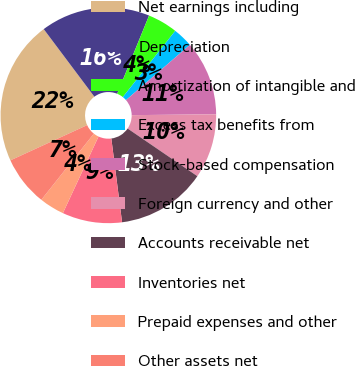Convert chart to OTSL. <chart><loc_0><loc_0><loc_500><loc_500><pie_chart><fcel>Net earnings including<fcel>Depreciation<fcel>Amortization of intangible and<fcel>Excess tax benefits from<fcel>Stock-based compensation<fcel>Foreign currency and other<fcel>Accounts receivable net<fcel>Inventories net<fcel>Prepaid expenses and other<fcel>Other assets net<nl><fcel>21.62%<fcel>16.4%<fcel>4.49%<fcel>3.0%<fcel>11.19%<fcel>9.7%<fcel>13.43%<fcel>8.96%<fcel>3.75%<fcel>7.47%<nl></chart> 